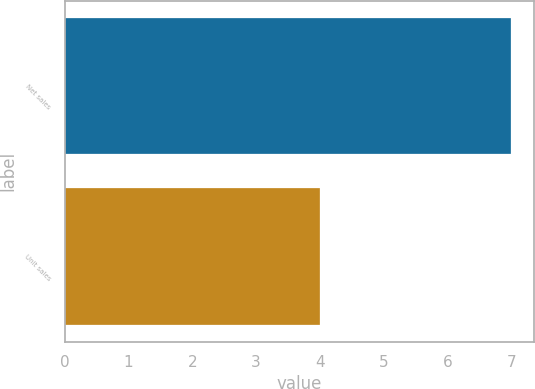Convert chart. <chart><loc_0><loc_0><loc_500><loc_500><bar_chart><fcel>Net sales<fcel>Unit sales<nl><fcel>7<fcel>4<nl></chart> 